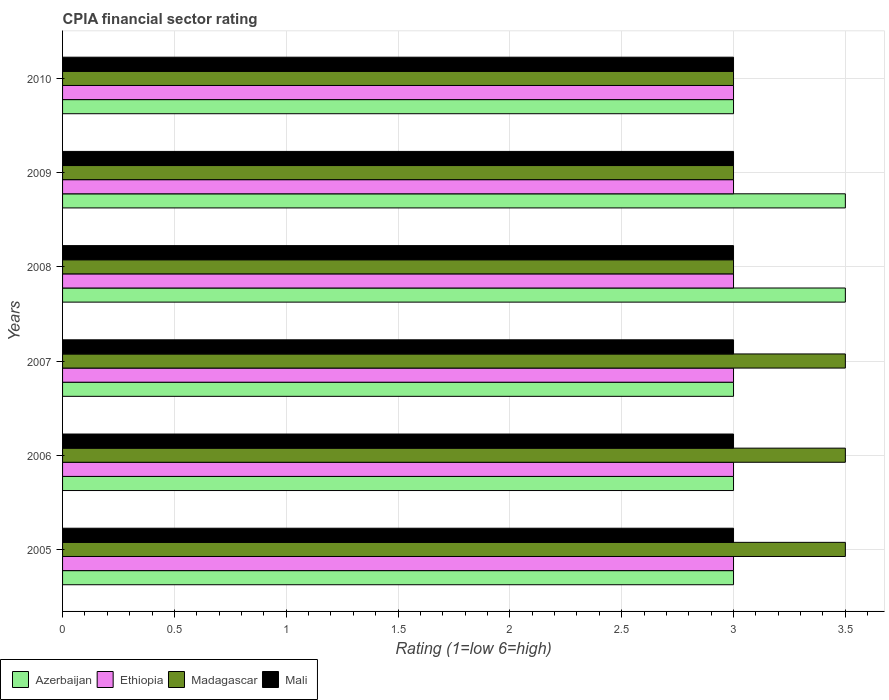What is the label of the 6th group of bars from the top?
Keep it short and to the point. 2005. In how many cases, is the number of bars for a given year not equal to the number of legend labels?
Make the answer very short. 0. What is the CPIA rating in Ethiopia in 2006?
Provide a short and direct response. 3. Across all years, what is the minimum CPIA rating in Ethiopia?
Keep it short and to the point. 3. In which year was the CPIA rating in Mali minimum?
Offer a terse response. 2005. What is the difference between the CPIA rating in Ethiopia in 2006 and the CPIA rating in Mali in 2005?
Your answer should be very brief. 0. What is the average CPIA rating in Azerbaijan per year?
Your response must be concise. 3.17. In how many years, is the CPIA rating in Azerbaijan greater than 3.5 ?
Your answer should be very brief. 0. What is the ratio of the CPIA rating in Mali in 2005 to that in 2010?
Provide a short and direct response. 1. Is the CPIA rating in Ethiopia in 2008 less than that in 2009?
Keep it short and to the point. No. Is the difference between the CPIA rating in Madagascar in 2007 and 2010 greater than the difference between the CPIA rating in Mali in 2007 and 2010?
Offer a very short reply. Yes. What is the difference between the highest and the second highest CPIA rating in Mali?
Provide a short and direct response. 0. What is the difference between the highest and the lowest CPIA rating in Madagascar?
Give a very brief answer. 0.5. In how many years, is the CPIA rating in Madagascar greater than the average CPIA rating in Madagascar taken over all years?
Ensure brevity in your answer.  3. Is the sum of the CPIA rating in Mali in 2007 and 2008 greater than the maximum CPIA rating in Azerbaijan across all years?
Your response must be concise. Yes. Is it the case that in every year, the sum of the CPIA rating in Azerbaijan and CPIA rating in Ethiopia is greater than the sum of CPIA rating in Madagascar and CPIA rating in Mali?
Your answer should be compact. No. What does the 3rd bar from the top in 2005 represents?
Offer a very short reply. Ethiopia. What does the 4th bar from the bottom in 2006 represents?
Provide a succinct answer. Mali. How many years are there in the graph?
Your answer should be compact. 6. What is the difference between two consecutive major ticks on the X-axis?
Your response must be concise. 0.5. Does the graph contain grids?
Offer a very short reply. Yes. Where does the legend appear in the graph?
Your answer should be compact. Bottom left. How are the legend labels stacked?
Your answer should be compact. Horizontal. What is the title of the graph?
Your answer should be compact. CPIA financial sector rating. What is the label or title of the Y-axis?
Make the answer very short. Years. What is the Rating (1=low 6=high) in Ethiopia in 2005?
Make the answer very short. 3. What is the Rating (1=low 6=high) in Madagascar in 2005?
Your response must be concise. 3.5. What is the Rating (1=low 6=high) of Mali in 2005?
Your answer should be compact. 3. What is the Rating (1=low 6=high) in Madagascar in 2006?
Provide a short and direct response. 3.5. What is the Rating (1=low 6=high) of Mali in 2006?
Offer a terse response. 3. What is the Rating (1=low 6=high) of Azerbaijan in 2008?
Keep it short and to the point. 3.5. What is the Rating (1=low 6=high) of Ethiopia in 2008?
Offer a terse response. 3. What is the Rating (1=low 6=high) of Ethiopia in 2009?
Ensure brevity in your answer.  3. What is the Rating (1=low 6=high) in Ethiopia in 2010?
Your answer should be compact. 3. What is the Rating (1=low 6=high) in Mali in 2010?
Keep it short and to the point. 3. Across all years, what is the maximum Rating (1=low 6=high) of Azerbaijan?
Offer a terse response. 3.5. Across all years, what is the maximum Rating (1=low 6=high) of Ethiopia?
Ensure brevity in your answer.  3. Across all years, what is the maximum Rating (1=low 6=high) in Madagascar?
Your answer should be compact. 3.5. Across all years, what is the minimum Rating (1=low 6=high) of Mali?
Offer a terse response. 3. What is the total Rating (1=low 6=high) of Ethiopia in the graph?
Your answer should be very brief. 18. What is the total Rating (1=low 6=high) of Madagascar in the graph?
Offer a terse response. 19.5. What is the difference between the Rating (1=low 6=high) in Ethiopia in 2005 and that in 2006?
Your answer should be very brief. 0. What is the difference between the Rating (1=low 6=high) of Madagascar in 2005 and that in 2006?
Ensure brevity in your answer.  0. What is the difference between the Rating (1=low 6=high) in Mali in 2005 and that in 2006?
Offer a very short reply. 0. What is the difference between the Rating (1=low 6=high) of Azerbaijan in 2005 and that in 2007?
Give a very brief answer. 0. What is the difference between the Rating (1=low 6=high) in Mali in 2005 and that in 2007?
Provide a short and direct response. 0. What is the difference between the Rating (1=low 6=high) in Madagascar in 2005 and that in 2008?
Provide a succinct answer. 0.5. What is the difference between the Rating (1=low 6=high) of Mali in 2005 and that in 2008?
Your answer should be very brief. 0. What is the difference between the Rating (1=low 6=high) in Madagascar in 2005 and that in 2009?
Your answer should be very brief. 0.5. What is the difference between the Rating (1=low 6=high) in Ethiopia in 2005 and that in 2010?
Your response must be concise. 0. What is the difference between the Rating (1=low 6=high) of Azerbaijan in 2006 and that in 2007?
Offer a very short reply. 0. What is the difference between the Rating (1=low 6=high) in Ethiopia in 2006 and that in 2007?
Provide a succinct answer. 0. What is the difference between the Rating (1=low 6=high) in Madagascar in 2006 and that in 2007?
Provide a succinct answer. 0. What is the difference between the Rating (1=low 6=high) of Mali in 2006 and that in 2007?
Provide a succinct answer. 0. What is the difference between the Rating (1=low 6=high) of Azerbaijan in 2006 and that in 2008?
Your answer should be compact. -0.5. What is the difference between the Rating (1=low 6=high) in Mali in 2006 and that in 2008?
Your response must be concise. 0. What is the difference between the Rating (1=low 6=high) of Madagascar in 2006 and that in 2009?
Offer a very short reply. 0.5. What is the difference between the Rating (1=low 6=high) of Azerbaijan in 2006 and that in 2010?
Make the answer very short. 0. What is the difference between the Rating (1=low 6=high) in Ethiopia in 2006 and that in 2010?
Offer a terse response. 0. What is the difference between the Rating (1=low 6=high) in Mali in 2006 and that in 2010?
Offer a terse response. 0. What is the difference between the Rating (1=low 6=high) of Azerbaijan in 2007 and that in 2008?
Keep it short and to the point. -0.5. What is the difference between the Rating (1=low 6=high) of Azerbaijan in 2007 and that in 2009?
Keep it short and to the point. -0.5. What is the difference between the Rating (1=low 6=high) of Ethiopia in 2007 and that in 2009?
Your answer should be compact. 0. What is the difference between the Rating (1=low 6=high) in Mali in 2007 and that in 2010?
Provide a succinct answer. 0. What is the difference between the Rating (1=low 6=high) in Azerbaijan in 2008 and that in 2009?
Ensure brevity in your answer.  0. What is the difference between the Rating (1=low 6=high) of Ethiopia in 2008 and that in 2009?
Keep it short and to the point. 0. What is the difference between the Rating (1=low 6=high) of Madagascar in 2008 and that in 2009?
Provide a short and direct response. 0. What is the difference between the Rating (1=low 6=high) of Mali in 2008 and that in 2009?
Your response must be concise. 0. What is the difference between the Rating (1=low 6=high) in Azerbaijan in 2008 and that in 2010?
Your answer should be compact. 0.5. What is the difference between the Rating (1=low 6=high) of Madagascar in 2008 and that in 2010?
Provide a short and direct response. 0. What is the difference between the Rating (1=low 6=high) in Azerbaijan in 2009 and that in 2010?
Your answer should be compact. 0.5. What is the difference between the Rating (1=low 6=high) in Azerbaijan in 2005 and the Rating (1=low 6=high) in Ethiopia in 2006?
Offer a very short reply. 0. What is the difference between the Rating (1=low 6=high) in Azerbaijan in 2005 and the Rating (1=low 6=high) in Madagascar in 2006?
Your answer should be very brief. -0.5. What is the difference between the Rating (1=low 6=high) of Azerbaijan in 2005 and the Rating (1=low 6=high) of Mali in 2006?
Provide a succinct answer. 0. What is the difference between the Rating (1=low 6=high) in Ethiopia in 2005 and the Rating (1=low 6=high) in Madagascar in 2006?
Make the answer very short. -0.5. What is the difference between the Rating (1=low 6=high) of Azerbaijan in 2005 and the Rating (1=low 6=high) of Ethiopia in 2007?
Keep it short and to the point. 0. What is the difference between the Rating (1=low 6=high) in Azerbaijan in 2005 and the Rating (1=low 6=high) in Mali in 2007?
Ensure brevity in your answer.  0. What is the difference between the Rating (1=low 6=high) in Ethiopia in 2005 and the Rating (1=low 6=high) in Mali in 2007?
Your answer should be very brief. 0. What is the difference between the Rating (1=low 6=high) in Azerbaijan in 2005 and the Rating (1=low 6=high) in Ethiopia in 2008?
Your answer should be very brief. 0. What is the difference between the Rating (1=low 6=high) in Azerbaijan in 2005 and the Rating (1=low 6=high) in Madagascar in 2008?
Offer a very short reply. 0. What is the difference between the Rating (1=low 6=high) of Azerbaijan in 2005 and the Rating (1=low 6=high) of Mali in 2008?
Keep it short and to the point. 0. What is the difference between the Rating (1=low 6=high) in Ethiopia in 2005 and the Rating (1=low 6=high) in Madagascar in 2008?
Provide a succinct answer. 0. What is the difference between the Rating (1=low 6=high) in Azerbaijan in 2005 and the Rating (1=low 6=high) in Ethiopia in 2009?
Provide a short and direct response. 0. What is the difference between the Rating (1=low 6=high) of Azerbaijan in 2005 and the Rating (1=low 6=high) of Madagascar in 2009?
Your response must be concise. 0. What is the difference between the Rating (1=low 6=high) of Azerbaijan in 2005 and the Rating (1=low 6=high) of Mali in 2009?
Offer a very short reply. 0. What is the difference between the Rating (1=low 6=high) of Ethiopia in 2005 and the Rating (1=low 6=high) of Mali in 2009?
Provide a short and direct response. 0. What is the difference between the Rating (1=low 6=high) of Azerbaijan in 2005 and the Rating (1=low 6=high) of Ethiopia in 2010?
Provide a short and direct response. 0. What is the difference between the Rating (1=low 6=high) in Azerbaijan in 2005 and the Rating (1=low 6=high) in Mali in 2010?
Ensure brevity in your answer.  0. What is the difference between the Rating (1=low 6=high) of Ethiopia in 2005 and the Rating (1=low 6=high) of Mali in 2010?
Provide a succinct answer. 0. What is the difference between the Rating (1=low 6=high) of Madagascar in 2005 and the Rating (1=low 6=high) of Mali in 2010?
Your response must be concise. 0.5. What is the difference between the Rating (1=low 6=high) of Azerbaijan in 2006 and the Rating (1=low 6=high) of Madagascar in 2007?
Your answer should be very brief. -0.5. What is the difference between the Rating (1=low 6=high) in Azerbaijan in 2006 and the Rating (1=low 6=high) in Mali in 2007?
Keep it short and to the point. 0. What is the difference between the Rating (1=low 6=high) of Madagascar in 2006 and the Rating (1=low 6=high) of Mali in 2007?
Make the answer very short. 0.5. What is the difference between the Rating (1=low 6=high) of Azerbaijan in 2006 and the Rating (1=low 6=high) of Ethiopia in 2008?
Offer a very short reply. 0. What is the difference between the Rating (1=low 6=high) of Azerbaijan in 2006 and the Rating (1=low 6=high) of Madagascar in 2008?
Your answer should be compact. 0. What is the difference between the Rating (1=low 6=high) in Madagascar in 2006 and the Rating (1=low 6=high) in Mali in 2008?
Make the answer very short. 0.5. What is the difference between the Rating (1=low 6=high) in Azerbaijan in 2006 and the Rating (1=low 6=high) in Ethiopia in 2009?
Give a very brief answer. 0. What is the difference between the Rating (1=low 6=high) in Azerbaijan in 2006 and the Rating (1=low 6=high) in Mali in 2009?
Your answer should be compact. 0. What is the difference between the Rating (1=low 6=high) of Ethiopia in 2006 and the Rating (1=low 6=high) of Madagascar in 2009?
Make the answer very short. 0. What is the difference between the Rating (1=low 6=high) in Madagascar in 2006 and the Rating (1=low 6=high) in Mali in 2009?
Offer a terse response. 0.5. What is the difference between the Rating (1=low 6=high) of Azerbaijan in 2006 and the Rating (1=low 6=high) of Ethiopia in 2010?
Provide a succinct answer. 0. What is the difference between the Rating (1=low 6=high) in Azerbaijan in 2006 and the Rating (1=low 6=high) in Mali in 2010?
Make the answer very short. 0. What is the difference between the Rating (1=low 6=high) of Madagascar in 2006 and the Rating (1=low 6=high) of Mali in 2010?
Provide a succinct answer. 0.5. What is the difference between the Rating (1=low 6=high) of Azerbaijan in 2007 and the Rating (1=low 6=high) of Ethiopia in 2008?
Provide a short and direct response. 0. What is the difference between the Rating (1=low 6=high) in Azerbaijan in 2007 and the Rating (1=low 6=high) in Mali in 2008?
Ensure brevity in your answer.  0. What is the difference between the Rating (1=low 6=high) of Ethiopia in 2007 and the Rating (1=low 6=high) of Madagascar in 2008?
Make the answer very short. 0. What is the difference between the Rating (1=low 6=high) of Azerbaijan in 2007 and the Rating (1=low 6=high) of Madagascar in 2009?
Ensure brevity in your answer.  0. What is the difference between the Rating (1=low 6=high) in Azerbaijan in 2007 and the Rating (1=low 6=high) in Mali in 2009?
Your answer should be compact. 0. What is the difference between the Rating (1=low 6=high) of Madagascar in 2007 and the Rating (1=low 6=high) of Mali in 2009?
Offer a terse response. 0.5. What is the difference between the Rating (1=low 6=high) in Azerbaijan in 2007 and the Rating (1=low 6=high) in Mali in 2010?
Your answer should be very brief. 0. What is the difference between the Rating (1=low 6=high) of Azerbaijan in 2008 and the Rating (1=low 6=high) of Ethiopia in 2009?
Keep it short and to the point. 0.5. What is the difference between the Rating (1=low 6=high) in Azerbaijan in 2008 and the Rating (1=low 6=high) in Madagascar in 2009?
Provide a succinct answer. 0.5. What is the difference between the Rating (1=low 6=high) of Azerbaijan in 2008 and the Rating (1=low 6=high) of Mali in 2009?
Provide a succinct answer. 0.5. What is the difference between the Rating (1=low 6=high) in Ethiopia in 2008 and the Rating (1=low 6=high) in Madagascar in 2009?
Provide a succinct answer. 0. What is the difference between the Rating (1=low 6=high) in Azerbaijan in 2008 and the Rating (1=low 6=high) in Ethiopia in 2010?
Ensure brevity in your answer.  0.5. What is the difference between the Rating (1=low 6=high) in Azerbaijan in 2008 and the Rating (1=low 6=high) in Madagascar in 2010?
Provide a succinct answer. 0.5. What is the difference between the Rating (1=low 6=high) of Azerbaijan in 2008 and the Rating (1=low 6=high) of Mali in 2010?
Your answer should be compact. 0.5. What is the difference between the Rating (1=low 6=high) of Ethiopia in 2008 and the Rating (1=low 6=high) of Madagascar in 2010?
Ensure brevity in your answer.  0. What is the difference between the Rating (1=low 6=high) of Ethiopia in 2008 and the Rating (1=low 6=high) of Mali in 2010?
Provide a succinct answer. 0. What is the difference between the Rating (1=low 6=high) of Azerbaijan in 2009 and the Rating (1=low 6=high) of Ethiopia in 2010?
Make the answer very short. 0.5. What is the difference between the Rating (1=low 6=high) in Azerbaijan in 2009 and the Rating (1=low 6=high) in Madagascar in 2010?
Keep it short and to the point. 0.5. What is the difference between the Rating (1=low 6=high) in Azerbaijan in 2009 and the Rating (1=low 6=high) in Mali in 2010?
Your answer should be compact. 0.5. What is the difference between the Rating (1=low 6=high) of Ethiopia in 2009 and the Rating (1=low 6=high) of Mali in 2010?
Your answer should be compact. 0. What is the difference between the Rating (1=low 6=high) in Madagascar in 2009 and the Rating (1=low 6=high) in Mali in 2010?
Ensure brevity in your answer.  0. What is the average Rating (1=low 6=high) of Azerbaijan per year?
Your answer should be very brief. 3.17. In the year 2005, what is the difference between the Rating (1=low 6=high) in Azerbaijan and Rating (1=low 6=high) in Ethiopia?
Provide a short and direct response. 0. In the year 2005, what is the difference between the Rating (1=low 6=high) of Azerbaijan and Rating (1=low 6=high) of Madagascar?
Your answer should be very brief. -0.5. In the year 2005, what is the difference between the Rating (1=low 6=high) of Ethiopia and Rating (1=low 6=high) of Mali?
Provide a short and direct response. 0. In the year 2005, what is the difference between the Rating (1=low 6=high) of Madagascar and Rating (1=low 6=high) of Mali?
Offer a very short reply. 0.5. In the year 2006, what is the difference between the Rating (1=low 6=high) in Azerbaijan and Rating (1=low 6=high) in Ethiopia?
Your response must be concise. 0. In the year 2006, what is the difference between the Rating (1=low 6=high) of Azerbaijan and Rating (1=low 6=high) of Mali?
Provide a succinct answer. 0. In the year 2007, what is the difference between the Rating (1=low 6=high) in Ethiopia and Rating (1=low 6=high) in Mali?
Make the answer very short. 0. In the year 2007, what is the difference between the Rating (1=low 6=high) in Madagascar and Rating (1=low 6=high) in Mali?
Offer a very short reply. 0.5. In the year 2008, what is the difference between the Rating (1=low 6=high) of Azerbaijan and Rating (1=low 6=high) of Madagascar?
Ensure brevity in your answer.  0.5. In the year 2008, what is the difference between the Rating (1=low 6=high) of Ethiopia and Rating (1=low 6=high) of Mali?
Make the answer very short. 0. In the year 2008, what is the difference between the Rating (1=low 6=high) of Madagascar and Rating (1=low 6=high) of Mali?
Offer a terse response. 0. In the year 2009, what is the difference between the Rating (1=low 6=high) in Azerbaijan and Rating (1=low 6=high) in Madagascar?
Your response must be concise. 0.5. In the year 2009, what is the difference between the Rating (1=low 6=high) in Azerbaijan and Rating (1=low 6=high) in Mali?
Your response must be concise. 0.5. In the year 2009, what is the difference between the Rating (1=low 6=high) in Ethiopia and Rating (1=low 6=high) in Mali?
Give a very brief answer. 0. In the year 2010, what is the difference between the Rating (1=low 6=high) of Azerbaijan and Rating (1=low 6=high) of Mali?
Ensure brevity in your answer.  0. In the year 2010, what is the difference between the Rating (1=low 6=high) of Ethiopia and Rating (1=low 6=high) of Madagascar?
Ensure brevity in your answer.  0. In the year 2010, what is the difference between the Rating (1=low 6=high) in Madagascar and Rating (1=low 6=high) in Mali?
Make the answer very short. 0. What is the ratio of the Rating (1=low 6=high) in Azerbaijan in 2005 to that in 2006?
Keep it short and to the point. 1. What is the ratio of the Rating (1=low 6=high) of Madagascar in 2005 to that in 2007?
Offer a very short reply. 1. What is the ratio of the Rating (1=low 6=high) of Madagascar in 2005 to that in 2008?
Give a very brief answer. 1.17. What is the ratio of the Rating (1=low 6=high) in Ethiopia in 2005 to that in 2009?
Offer a terse response. 1. What is the ratio of the Rating (1=low 6=high) in Madagascar in 2005 to that in 2009?
Your answer should be very brief. 1.17. What is the ratio of the Rating (1=low 6=high) of Azerbaijan in 2005 to that in 2010?
Keep it short and to the point. 1. What is the ratio of the Rating (1=low 6=high) in Ethiopia in 2005 to that in 2010?
Ensure brevity in your answer.  1. What is the ratio of the Rating (1=low 6=high) of Azerbaijan in 2006 to that in 2007?
Provide a short and direct response. 1. What is the ratio of the Rating (1=low 6=high) in Ethiopia in 2006 to that in 2008?
Your answer should be very brief. 1. What is the ratio of the Rating (1=low 6=high) of Azerbaijan in 2006 to that in 2009?
Provide a short and direct response. 0.86. What is the ratio of the Rating (1=low 6=high) in Azerbaijan in 2006 to that in 2010?
Your answer should be compact. 1. What is the ratio of the Rating (1=low 6=high) of Ethiopia in 2006 to that in 2010?
Make the answer very short. 1. What is the ratio of the Rating (1=low 6=high) in Madagascar in 2006 to that in 2010?
Offer a very short reply. 1.17. What is the ratio of the Rating (1=low 6=high) in Mali in 2006 to that in 2010?
Provide a short and direct response. 1. What is the ratio of the Rating (1=low 6=high) in Azerbaijan in 2007 to that in 2009?
Provide a succinct answer. 0.86. What is the ratio of the Rating (1=low 6=high) of Madagascar in 2007 to that in 2009?
Give a very brief answer. 1.17. What is the ratio of the Rating (1=low 6=high) of Mali in 2007 to that in 2009?
Make the answer very short. 1. What is the ratio of the Rating (1=low 6=high) of Ethiopia in 2007 to that in 2010?
Your answer should be compact. 1. What is the ratio of the Rating (1=low 6=high) in Madagascar in 2007 to that in 2010?
Provide a short and direct response. 1.17. What is the ratio of the Rating (1=low 6=high) in Mali in 2008 to that in 2009?
Your response must be concise. 1. What is the ratio of the Rating (1=low 6=high) of Azerbaijan in 2008 to that in 2010?
Your answer should be very brief. 1.17. What is the ratio of the Rating (1=low 6=high) in Ethiopia in 2008 to that in 2010?
Keep it short and to the point. 1. What is the ratio of the Rating (1=low 6=high) of Mali in 2008 to that in 2010?
Your answer should be compact. 1. What is the ratio of the Rating (1=low 6=high) in Madagascar in 2009 to that in 2010?
Give a very brief answer. 1. What is the difference between the highest and the second highest Rating (1=low 6=high) of Azerbaijan?
Your answer should be compact. 0. What is the difference between the highest and the second highest Rating (1=low 6=high) in Ethiopia?
Ensure brevity in your answer.  0. What is the difference between the highest and the second highest Rating (1=low 6=high) in Madagascar?
Offer a very short reply. 0. What is the difference between the highest and the second highest Rating (1=low 6=high) in Mali?
Offer a terse response. 0. What is the difference between the highest and the lowest Rating (1=low 6=high) of Madagascar?
Your answer should be very brief. 0.5. 